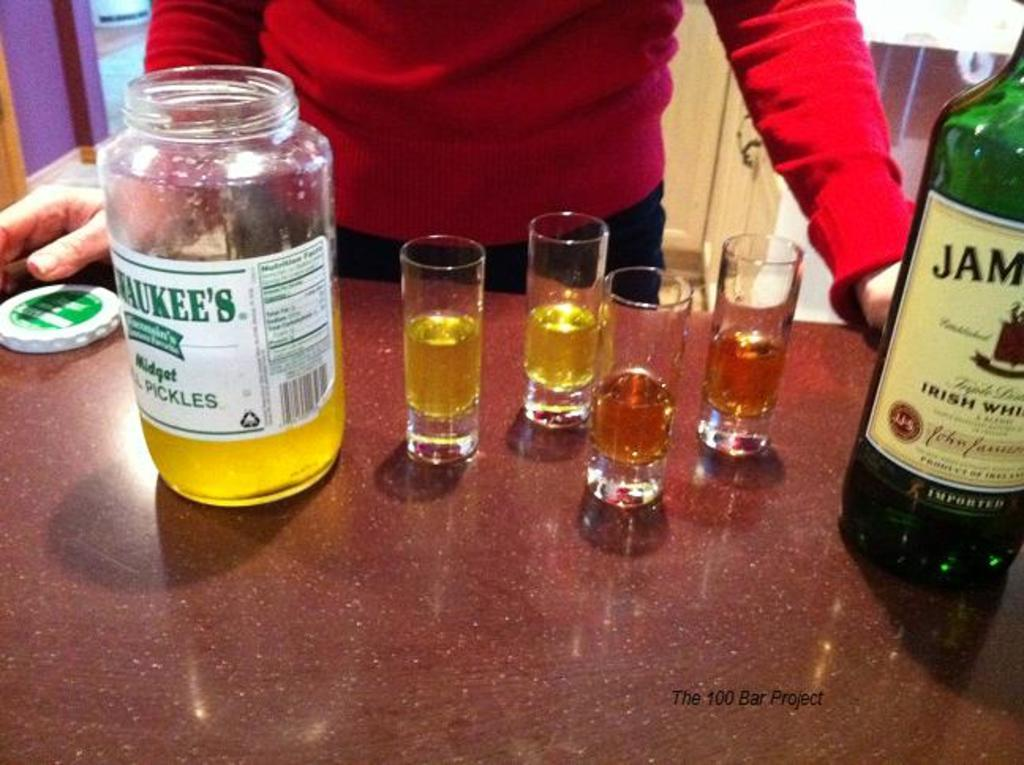Provide a one-sentence caption for the provided image. opened bottle with tequile shot glasses of irish whisky. 